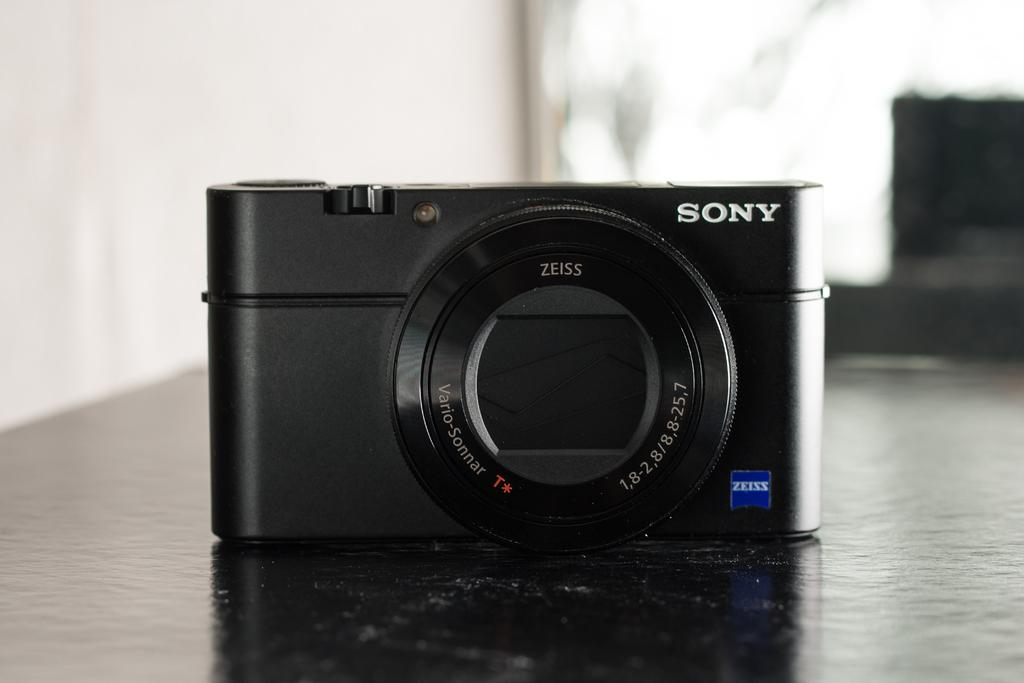<image>
Create a compact narrative representing the image presented. Black camera which says SONY on the top right. 